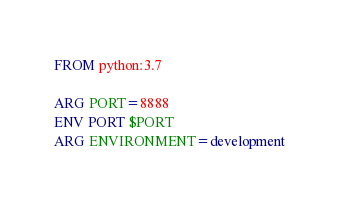<code> <loc_0><loc_0><loc_500><loc_500><_Dockerfile_>FROM python:3.7

ARG PORT=8888
ENV PORT $PORT
ARG ENVIRONMENT=development</code> 